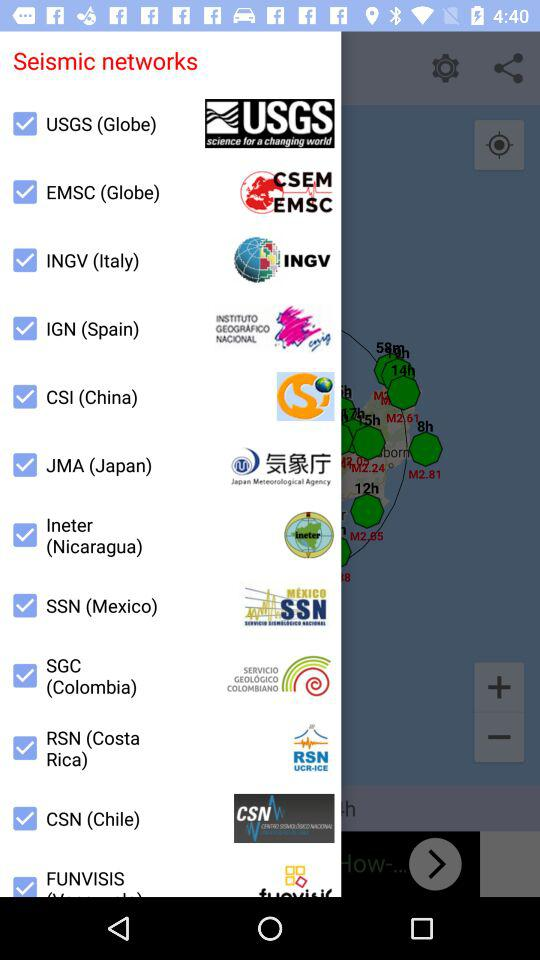What is the seismic network of Spain? The seismic network of Spain is IGN. 